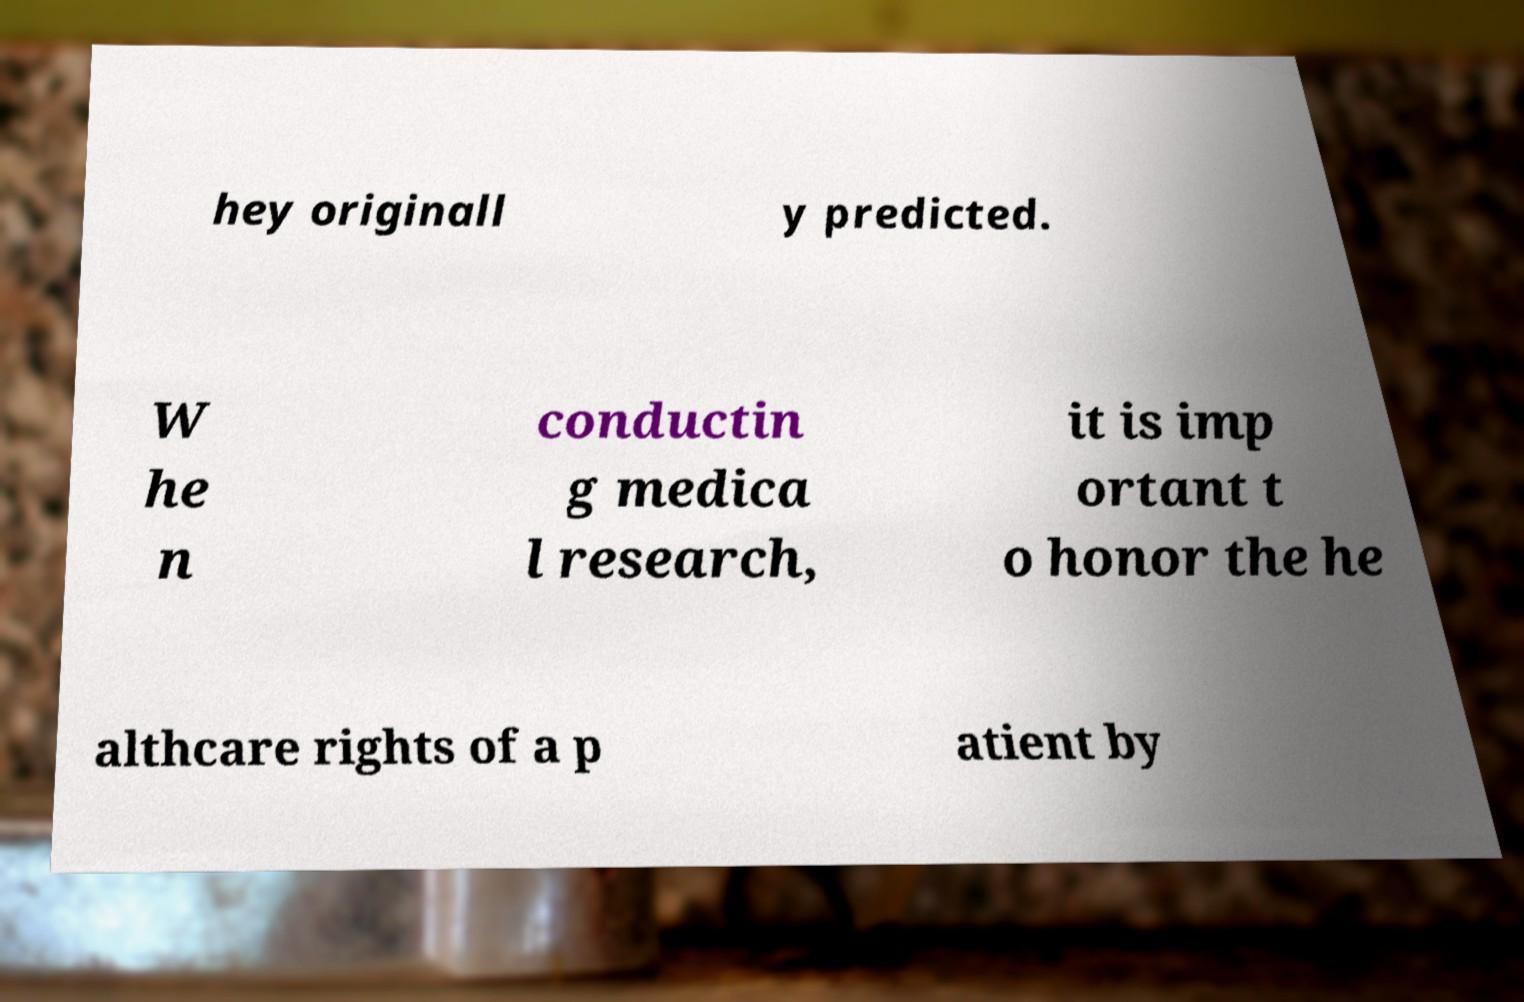Could you assist in decoding the text presented in this image and type it out clearly? hey originall y predicted. W he n conductin g medica l research, it is imp ortant t o honor the he althcare rights of a p atient by 